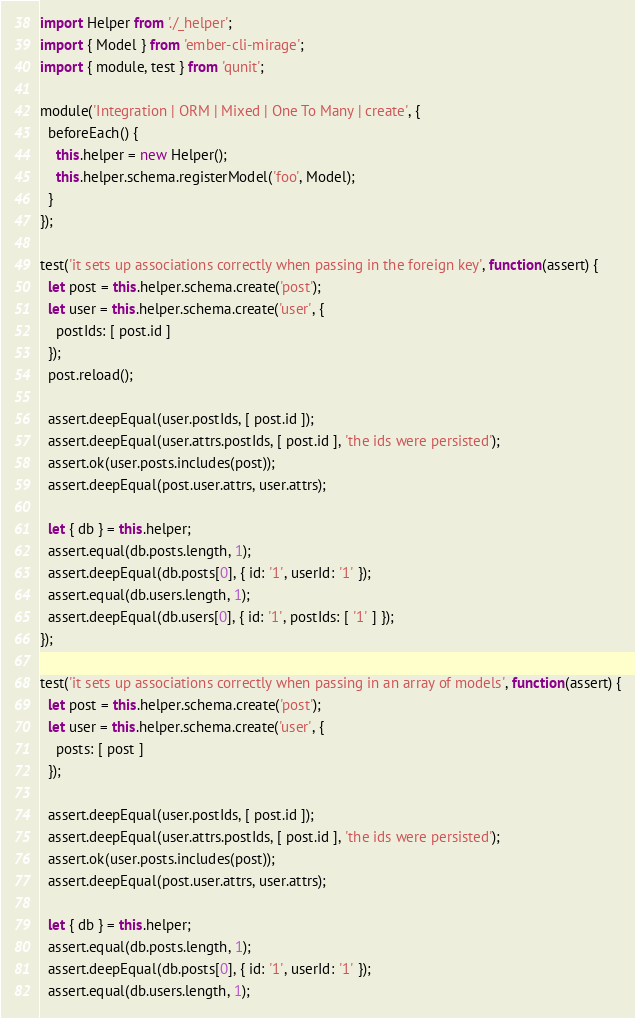Convert code to text. <code><loc_0><loc_0><loc_500><loc_500><_JavaScript_>import Helper from './_helper';
import { Model } from 'ember-cli-mirage';
import { module, test } from 'qunit';

module('Integration | ORM | Mixed | One To Many | create', {
  beforeEach() {
    this.helper = new Helper();
    this.helper.schema.registerModel('foo', Model);
  }
});

test('it sets up associations correctly when passing in the foreign key', function(assert) {
  let post = this.helper.schema.create('post');
  let user = this.helper.schema.create('user', {
    postIds: [ post.id ]
  });
  post.reload();

  assert.deepEqual(user.postIds, [ post.id ]);
  assert.deepEqual(user.attrs.postIds, [ post.id ], 'the ids were persisted');
  assert.ok(user.posts.includes(post));
  assert.deepEqual(post.user.attrs, user.attrs);

  let { db } = this.helper;
  assert.equal(db.posts.length, 1);
  assert.deepEqual(db.posts[0], { id: '1', userId: '1' });
  assert.equal(db.users.length, 1);
  assert.deepEqual(db.users[0], { id: '1', postIds: [ '1' ] });
});

test('it sets up associations correctly when passing in an array of models', function(assert) {
  let post = this.helper.schema.create('post');
  let user = this.helper.schema.create('user', {
    posts: [ post ]
  });

  assert.deepEqual(user.postIds, [ post.id ]);
  assert.deepEqual(user.attrs.postIds, [ post.id ], 'the ids were persisted');
  assert.ok(user.posts.includes(post));
  assert.deepEqual(post.user.attrs, user.attrs);

  let { db } = this.helper;
  assert.equal(db.posts.length, 1);
  assert.deepEqual(db.posts[0], { id: '1', userId: '1' });
  assert.equal(db.users.length, 1);</code> 